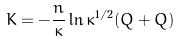Convert formula to latex. <formula><loc_0><loc_0><loc_500><loc_500>K = - \frac { n } { \kappa } \ln \kappa ^ { 1 / 2 } ( Q + \bar { Q } )</formula> 